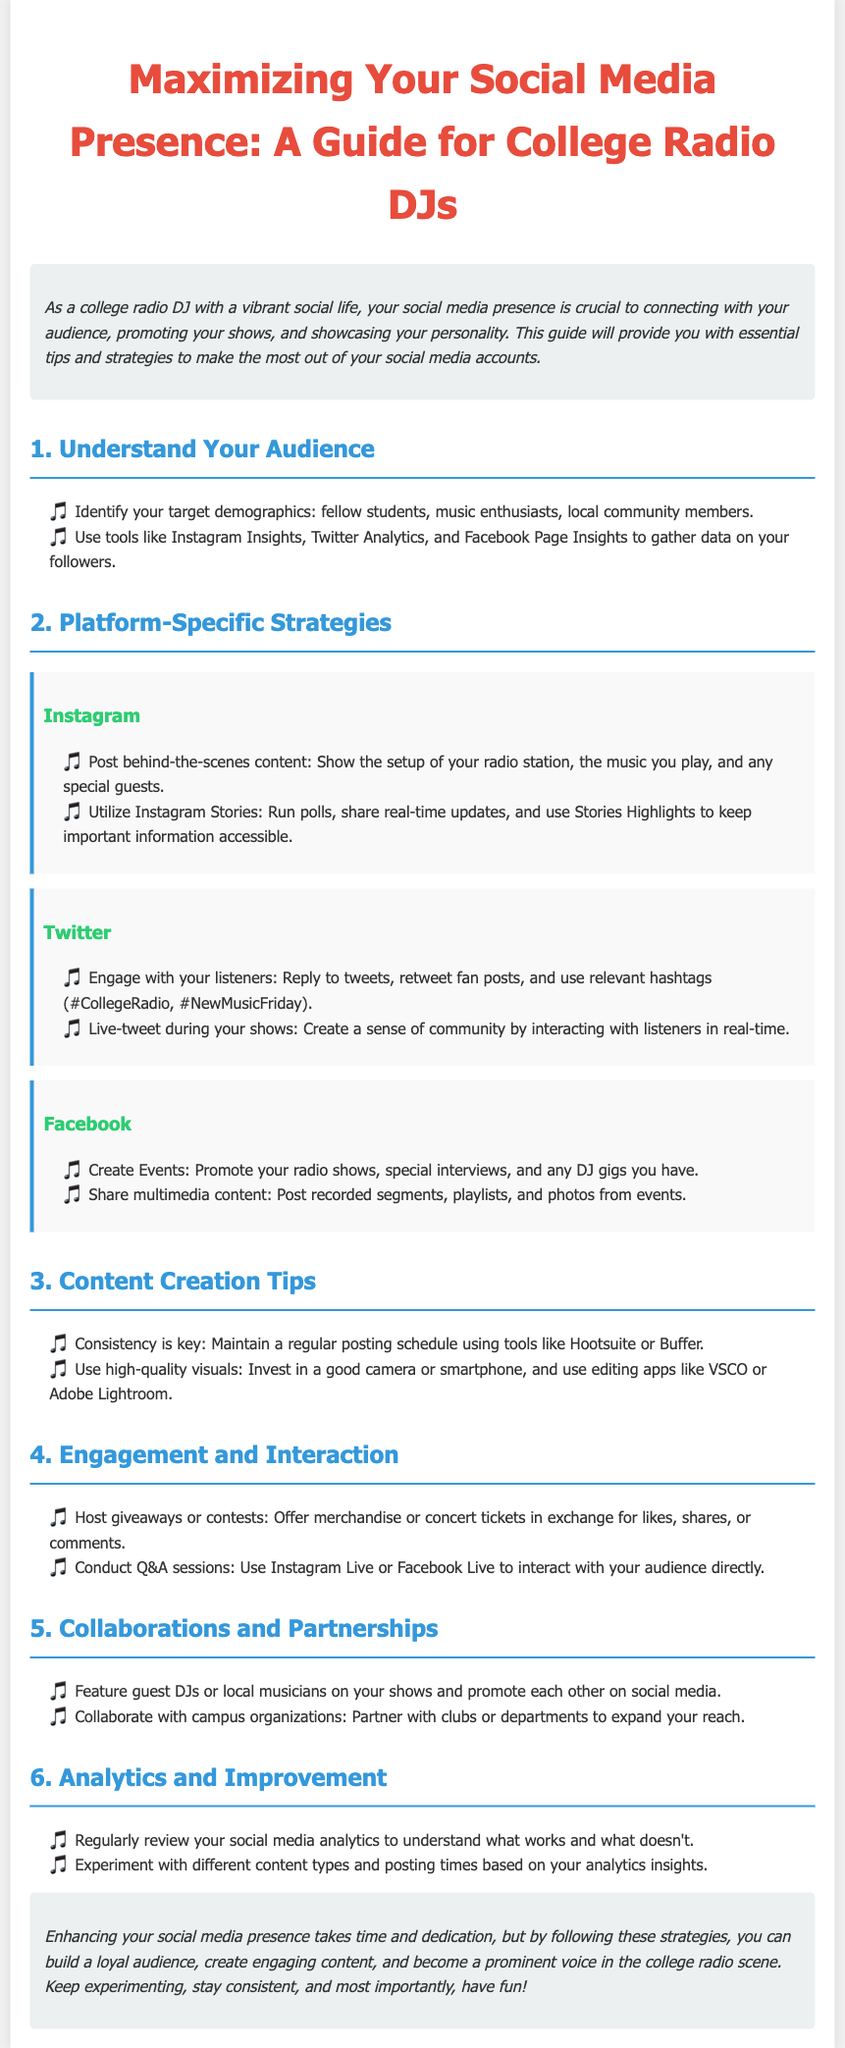What is the main purpose of the guide? The main purpose of the guide is to provide essential tips and strategies for college radio DJs to maximize their social media presence.
Answer: To maximize social media presence Which social media platform suggests using polls? The document recommends utilizing polls on Instagram Stories for engagement.
Answer: Instagram What should you regularly review to improve your social media presence? Regular review of social media analytics is necessary to understand performance and improve strategies.
Answer: Social media analytics What is one way to engage your audience during a show? One way to engage the audience is by live-tweeting during shows to create a sense of community.
Answer: Live-tweeting What content type should you use for consistency? The guide suggests maintaining a regular posting schedule using tools for consistency in content types.
Answer: Regular posting schedule What is recommended for content creation quality? High-quality visuals are recommended, suggesting the use of a good camera or smartphone for content creation.
Answer: High-quality visuals How can DJs collaborate with local musicians? DJs can feature guest DJs or local musicians on their shows and promote each other on social media.
Answer: Feature guest DJs What should DJs offer in exchange for likes and shares? Hosting giveaways or contests with merchandise or concert tickets is suggested for engagement.
Answer: Merchandise or concert tickets Which platform allows for real-time audience interaction? Instagram Live or Facebook Live can be used for conducting Q&A sessions to interact in real-time.
Answer: Instagram Live or Facebook Live 